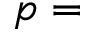Convert formula to latex. <formula><loc_0><loc_0><loc_500><loc_500>p =</formula> 